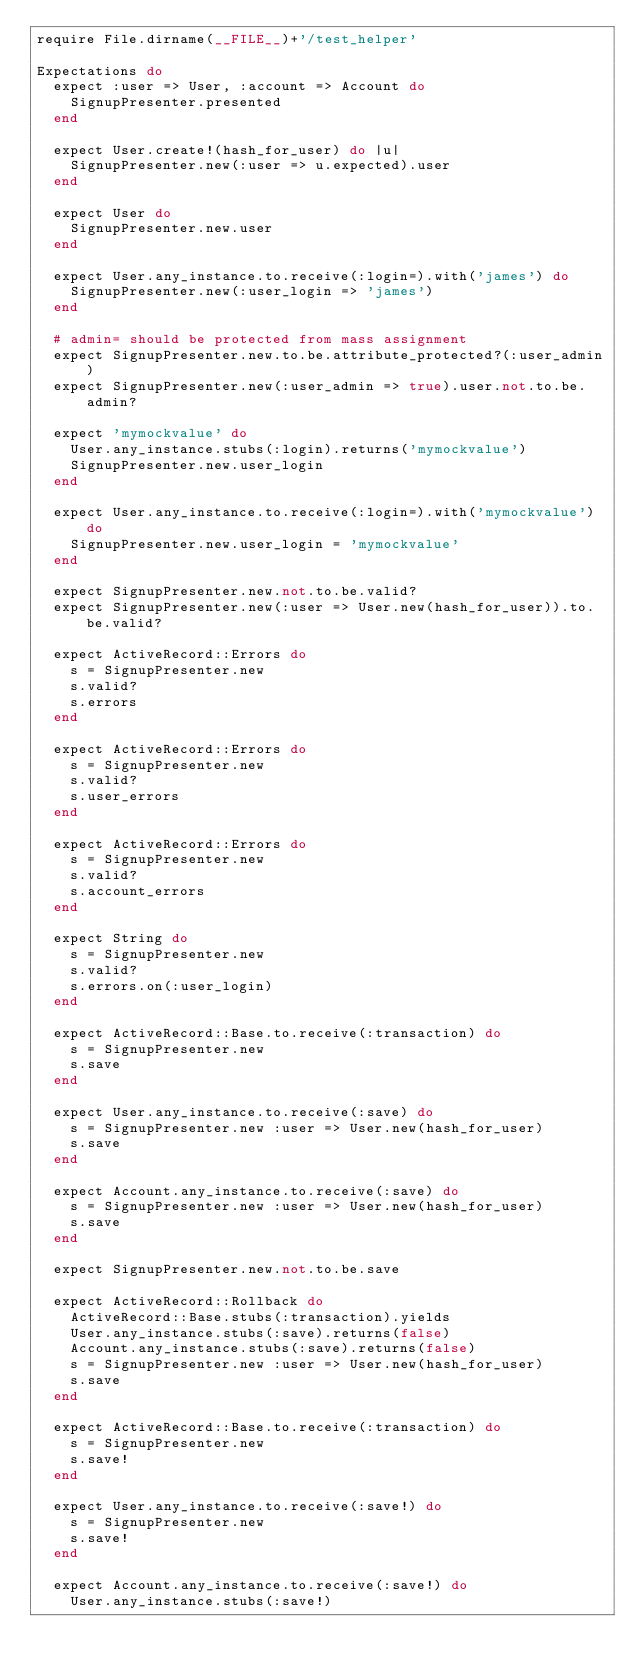<code> <loc_0><loc_0><loc_500><loc_500><_Ruby_>require File.dirname(__FILE__)+'/test_helper'

Expectations do
  expect :user => User, :account => Account do
    SignupPresenter.presented
  end
  
  expect User.create!(hash_for_user) do |u|
    SignupPresenter.new(:user => u.expected).user
  end
  
  expect User do
    SignupPresenter.new.user
  end
  
  expect User.any_instance.to.receive(:login=).with('james') do
    SignupPresenter.new(:user_login => 'james')
  end
  
  # admin= should be protected from mass assignment
  expect SignupPresenter.new.to.be.attribute_protected?(:user_admin)
  expect SignupPresenter.new(:user_admin => true).user.not.to.be.admin?
  
  expect 'mymockvalue' do
    User.any_instance.stubs(:login).returns('mymockvalue')
    SignupPresenter.new.user_login
  end
  
  expect User.any_instance.to.receive(:login=).with('mymockvalue') do
    SignupPresenter.new.user_login = 'mymockvalue'
  end
  
  expect SignupPresenter.new.not.to.be.valid?
  expect SignupPresenter.new(:user => User.new(hash_for_user)).to.be.valid?
  
  expect ActiveRecord::Errors do
    s = SignupPresenter.new
    s.valid?
    s.errors
  end
  
  expect ActiveRecord::Errors do
    s = SignupPresenter.new
    s.valid?
    s.user_errors
  end
  
  expect ActiveRecord::Errors do
    s = SignupPresenter.new
    s.valid?
    s.account_errors
  end
  
  expect String do
    s = SignupPresenter.new
    s.valid?
    s.errors.on(:user_login)
  end
  
  expect ActiveRecord::Base.to.receive(:transaction) do
    s = SignupPresenter.new
    s.save
  end
  
  expect User.any_instance.to.receive(:save) do
    s = SignupPresenter.new :user => User.new(hash_for_user)
    s.save
  end
  
  expect Account.any_instance.to.receive(:save) do
    s = SignupPresenter.new :user => User.new(hash_for_user)
    s.save
  end
  
  expect SignupPresenter.new.not.to.be.save
  
  expect ActiveRecord::Rollback do
    ActiveRecord::Base.stubs(:transaction).yields
    User.any_instance.stubs(:save).returns(false)
    Account.any_instance.stubs(:save).returns(false)
    s = SignupPresenter.new :user => User.new(hash_for_user)
    s.save
  end
  
  expect ActiveRecord::Base.to.receive(:transaction) do
    s = SignupPresenter.new
    s.save!
  end
  
  expect User.any_instance.to.receive(:save!) do
    s = SignupPresenter.new
    s.save!
  end
  
  expect Account.any_instance.to.receive(:save!) do
    User.any_instance.stubs(:save!)</code> 